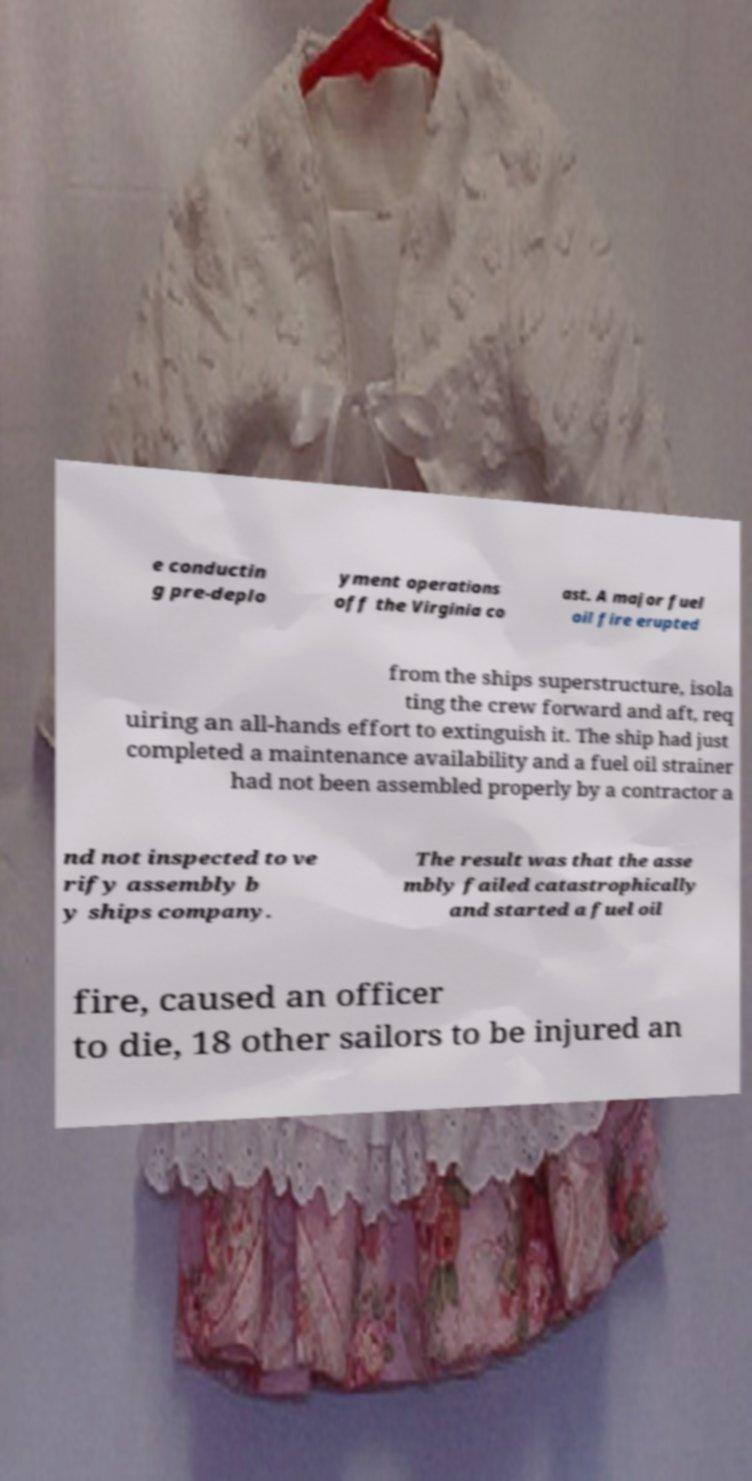I need the written content from this picture converted into text. Can you do that? e conductin g pre-deplo yment operations off the Virginia co ast. A major fuel oil fire erupted from the ships superstructure, isola ting the crew forward and aft, req uiring an all-hands effort to extinguish it. The ship had just completed a maintenance availability and a fuel oil strainer had not been assembled properly by a contractor a nd not inspected to ve rify assembly b y ships company. The result was that the asse mbly failed catastrophically and started a fuel oil fire, caused an officer to die, 18 other sailors to be injured an 